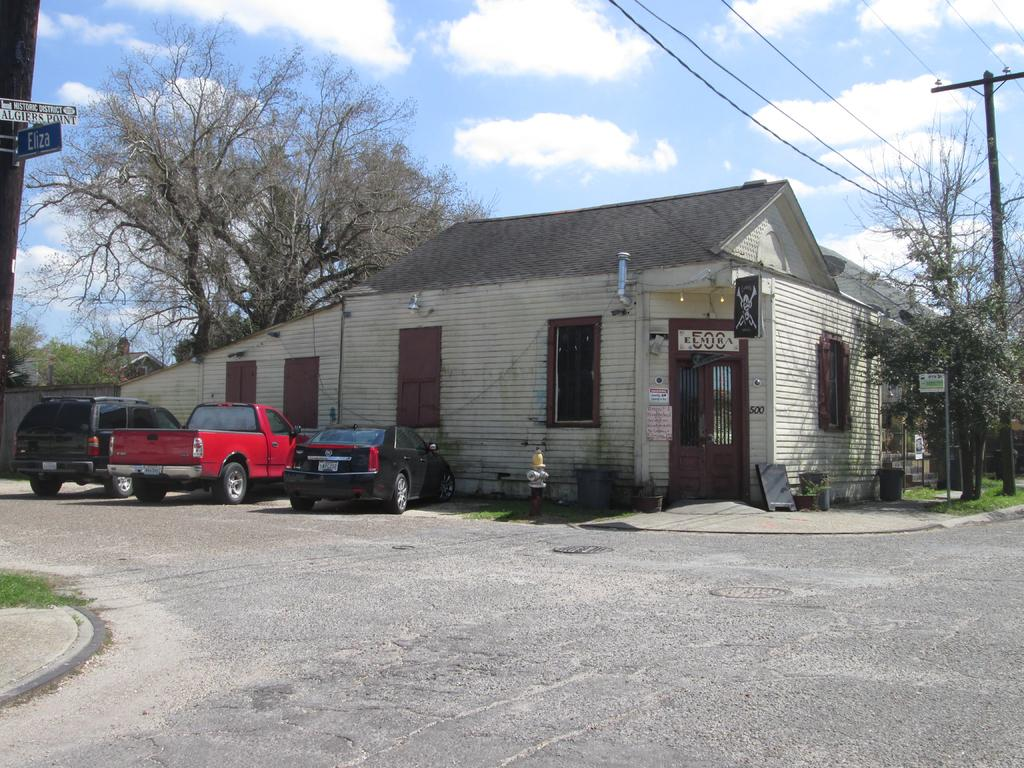What can be seen on the poles in the image? There are boards on poles in the image. What is happening on the road in the image? Vehicles are parked on the road in the image. What is attached to the pole in the image? There is a pole with wires in the image. What type of vegetation is visible in the image? Grass is visible in the image. What type of structure can be seen in the image? There is a house in the image. What is visible in the background of the image? Trees are present in the background of the image. What is the condition of the sky in the image? The sky is cloudy in the image. How many eggs are visible on the roof of the house in the image? There are no eggs visible on the roof of the house in the image. What type of bridge can be seen connecting the trees in the background? There is no bridge present in the image; it only features trees in the background. 